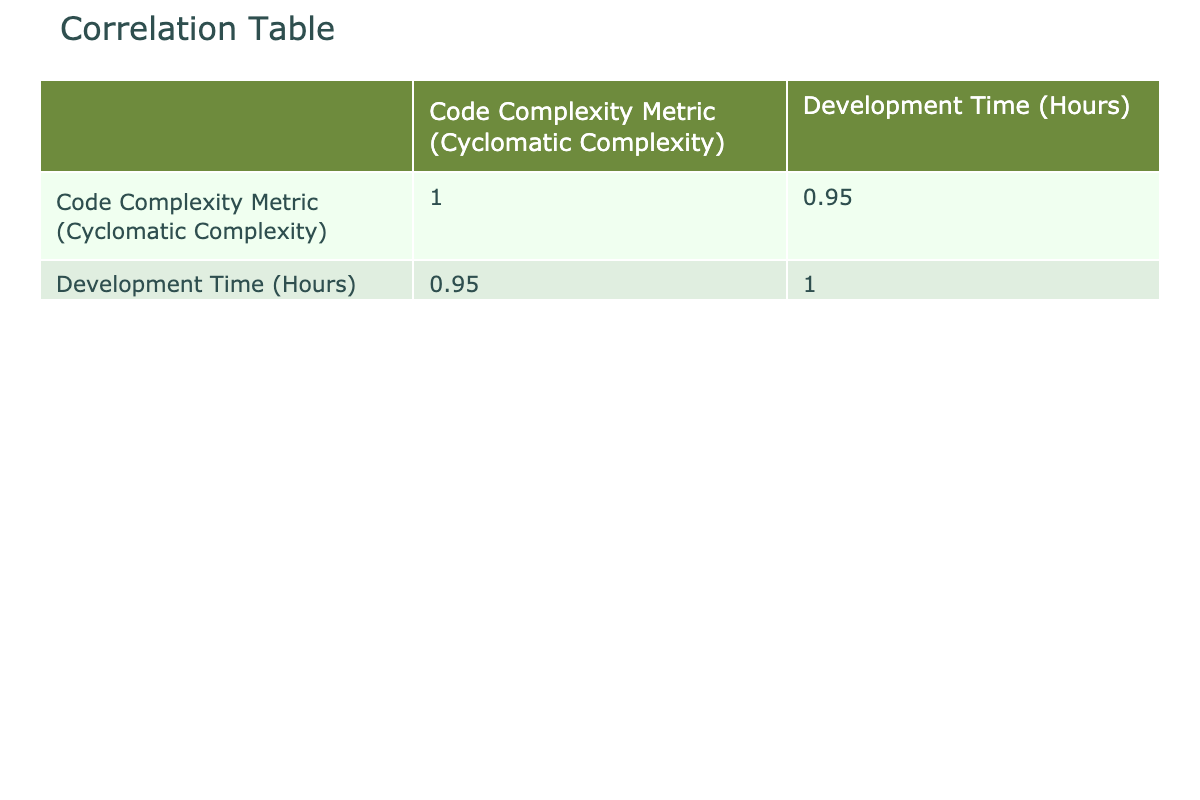What is the code complexity metric for TensorFlow? From the table, we can directly locate the row corresponding to TensorFlow, which indicates that the code complexity metric is 25.
Answer: 25 Which project has the highest development time? By looking at the development time column, we find that the Linux Kernel has the highest value at 1200 hours.
Answer: Linux Kernel What is the average code complexity metric for all projects? To find the average, we sum all code complexity metrics (25 + 19 + 34 + 15 + 21 + 28 + 40 + 22 + 18 + 27 =  289) and divide by the number of projects (10). Thus, the average is 289/10 = 28.9.
Answer: 28.9 Is the development time of Django less than that of Flask? According to the table, Django has a development time of 400 hours, while Flask has 200 hours. Since 400 is greater than 200, the answer is no.
Answer: No What is the difference in development time between Kubernetes and Apache Spark? From the table, Kubernetes has a development time of 800 hours and Apache Spark has 650 hours. Subtracting these values (800 - 650) gives us 150 hours.
Answer: 150 Which projects have a code complexity metric greater than 20? By examining the 'Code Complexity Metric' column, projects with a metric greater than 20 include TensorFlow (25), Kubernetes (34), Apache Spark (28), OpenJDK (27), and Ansible (22). This results in five projects.
Answer: 5 What is the total development time of the projects with a code complexity metric less than 20? We identify the projects with metrics less than 20: Flask (200), Django (400), and Ruby on Rails (450). Adding these development times together (200 + 400 + 450) yields 1050 hours.
Answer: 1050 Does a higher code complexity metric always correspond to longer development time? To evaluate this, we need to check if each project follows this trend. However, from the data, we notice exceptions like React and Flask where Flask has a lower complexity but less development time. Therefore, the statement is false.
Answer: No What percentage of the total development time is attributed to the Linux Kernel? The Linux Kernel has a development time of 1200 hours. The total development time for all projects is 500 + 400 + 800 + 200 + 350 + 650 + 1200 + 300 + 450 + 700 = 4150 hours. To find the percentage, we do (1200 / 4150) * 100, which results in approximately 28.92%.
Answer: 28.92% 